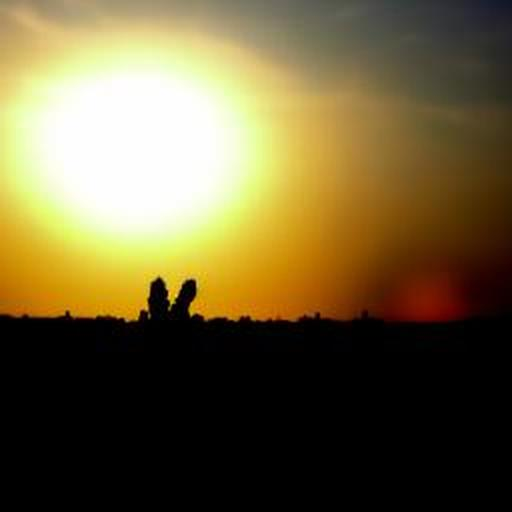Are there any quality issues with this image? Yes, there are some quality issues with the image. The silhouette against the sunset is beautifully captured, providing a striking contrast, but the image appears to be somewhat pixelated and overexposed in the areas surrounding the sun, which can detract from the overall clarity and detail. 